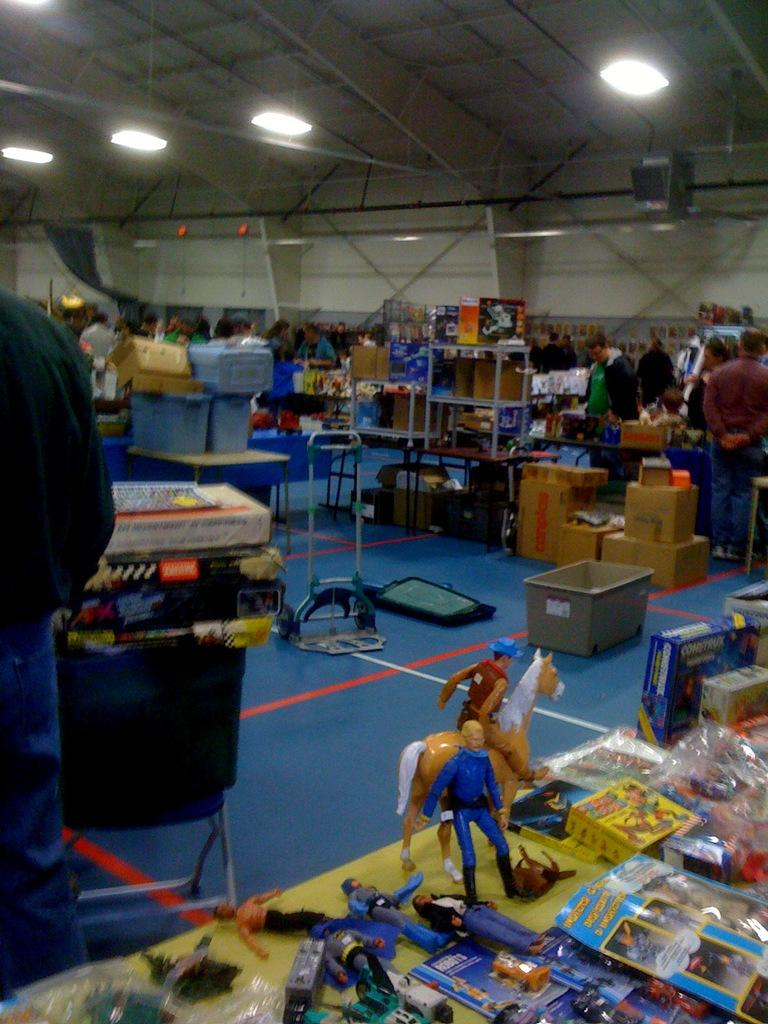Where was the image taken? The image was taken in a storage unit. What can be seen on the desk in the image? There are many toys on the desk. What is visible in the background of the image? There are cardboard boxes in the background. What is happening in the storage unit? People are walking around in the storage unit. What time does the clock on the desk show in the image? There is no clock present in the image. What type of bottle can be seen on the desk in the image? There are no bottles visible on the desk in the image. 